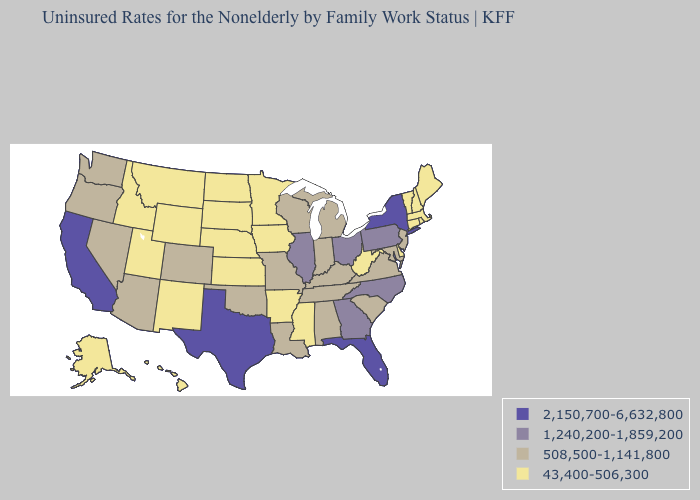What is the value of Montana?
Give a very brief answer. 43,400-506,300. Name the states that have a value in the range 508,500-1,141,800?
Keep it brief. Alabama, Arizona, Colorado, Indiana, Kentucky, Louisiana, Maryland, Michigan, Missouri, Nevada, New Jersey, Oklahoma, Oregon, South Carolina, Tennessee, Virginia, Washington, Wisconsin. Among the states that border Florida , which have the highest value?
Write a very short answer. Georgia. Among the states that border Alabama , which have the lowest value?
Quick response, please. Mississippi. Name the states that have a value in the range 43,400-506,300?
Be succinct. Alaska, Arkansas, Connecticut, Delaware, Hawaii, Idaho, Iowa, Kansas, Maine, Massachusetts, Minnesota, Mississippi, Montana, Nebraska, New Hampshire, New Mexico, North Dakota, Rhode Island, South Dakota, Utah, Vermont, West Virginia, Wyoming. What is the highest value in states that border North Dakota?
Keep it brief. 43,400-506,300. Among the states that border North Carolina , does Tennessee have the lowest value?
Keep it brief. Yes. Name the states that have a value in the range 508,500-1,141,800?
Keep it brief. Alabama, Arizona, Colorado, Indiana, Kentucky, Louisiana, Maryland, Michigan, Missouri, Nevada, New Jersey, Oklahoma, Oregon, South Carolina, Tennessee, Virginia, Washington, Wisconsin. Which states have the highest value in the USA?
Answer briefly. California, Florida, New York, Texas. Name the states that have a value in the range 2,150,700-6,632,800?
Keep it brief. California, Florida, New York, Texas. Name the states that have a value in the range 2,150,700-6,632,800?
Be succinct. California, Florida, New York, Texas. What is the value of South Carolina?
Be succinct. 508,500-1,141,800. What is the highest value in the South ?
Be succinct. 2,150,700-6,632,800. Name the states that have a value in the range 508,500-1,141,800?
Write a very short answer. Alabama, Arizona, Colorado, Indiana, Kentucky, Louisiana, Maryland, Michigan, Missouri, Nevada, New Jersey, Oklahoma, Oregon, South Carolina, Tennessee, Virginia, Washington, Wisconsin. How many symbols are there in the legend?
Short answer required. 4. 